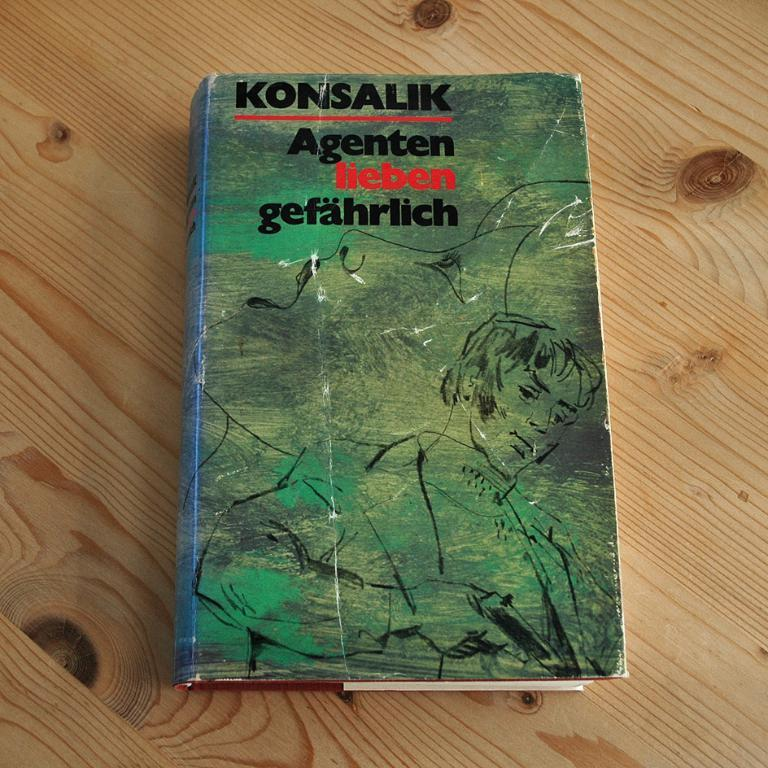<image>
Write a terse but informative summary of the picture. The cover of a Konsalik book is green with sketches of two people on it. 